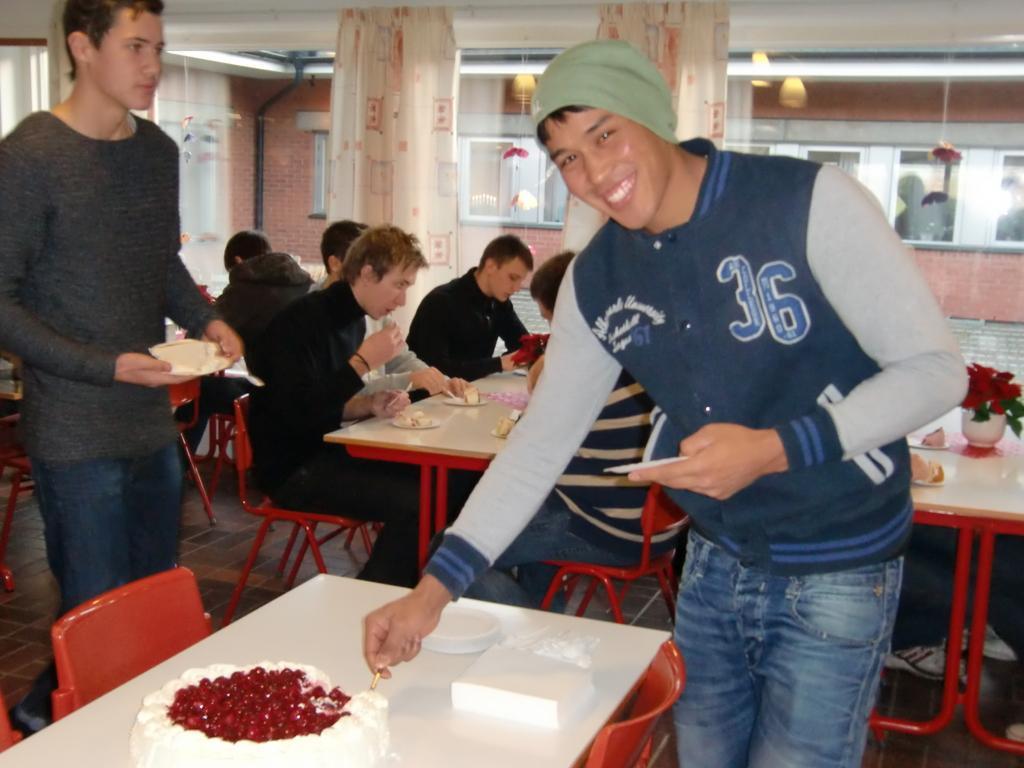Describe this image in one or two sentences. In this image I see 2 men who are standing and I see that this man is smiling. In the background I see few people who are sitting on chairs and there are tables in front of them and there are few things on it. 